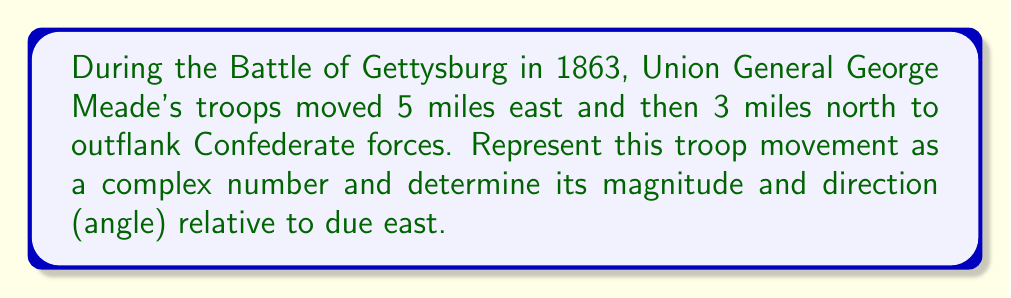Can you solve this math problem? To solve this problem, we'll use complex numbers to represent the troop movement vector, then calculate its magnitude and direction.

1. Represent the movement as a complex number:
   - 5 miles east: real part = 5
   - 3 miles north: imaginary part = 3i
   
   The complex number is: $z = 5 + 3i$

2. Calculate the magnitude (distance):
   The magnitude is given by the absolute value of the complex number:
   $$|z| = \sqrt{a^2 + b^2}$$
   where $a$ is the real part and $b$ is the imaginary part.

   $$|z| = \sqrt{5^2 + 3^2} = \sqrt{25 + 9} = \sqrt{34} \approx 5.83$$

3. Calculate the direction (angle):
   The angle $\theta$ is given by the argument of the complex number:
   $$\theta = \arg(z) = \tan^{-1}\left(\frac{b}{a}\right)$$

   $$\theta = \tan^{-1}\left(\frac{3}{5}\right) \approx 0.5404 \text{ radians}$$

   To convert to degrees:
   $$\theta \approx 0.5404 \times \frac{180°}{\pi} \approx 30.96°$$

The angle is measured counterclockwise from the positive real axis (east).
Answer: Magnitude: $\sqrt{34} \approx 5.83$ miles
Direction: $30.96°$ north of east 